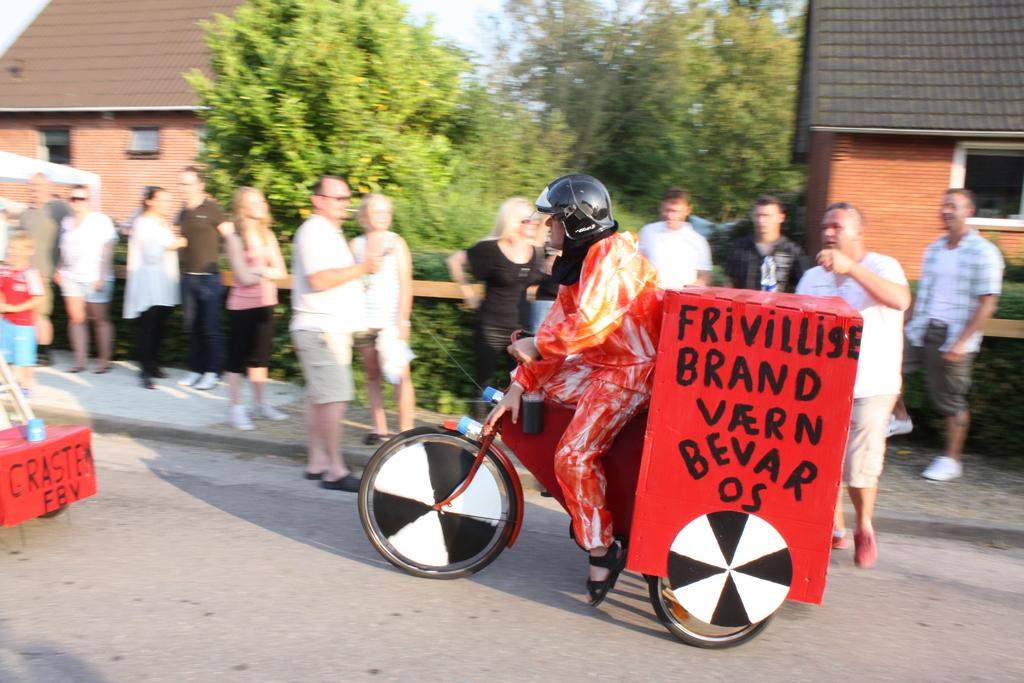What is the person in the image doing? The person in the image is riding a bicycle. What is attached to the back of the bicycle? The bicycle has a box on the back. Who else is present in the image besides the person riding the bicycle? There are people standing nearby in the image. What type of structures can be seen in the background of the image? There are houses visible in the image. What type of vegetation is present in the image? Trees are present in the image. What type of stew is being served on the cushion in the image? There is no stew or cushion present in the image. 